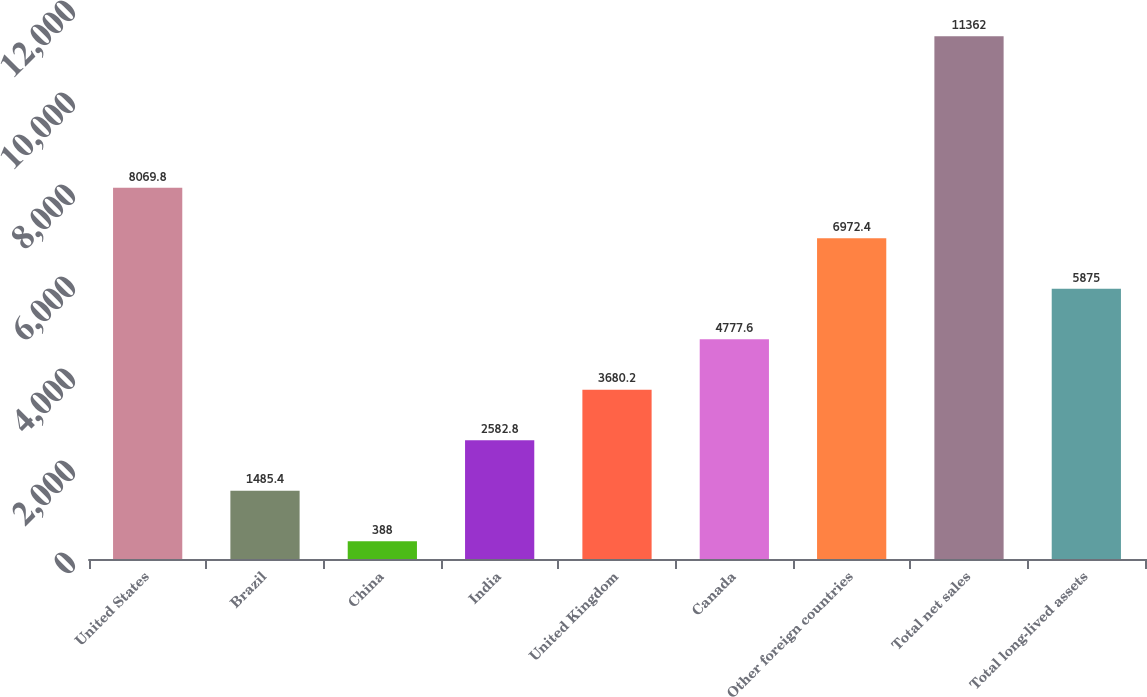Convert chart. <chart><loc_0><loc_0><loc_500><loc_500><bar_chart><fcel>United States<fcel>Brazil<fcel>China<fcel>India<fcel>United Kingdom<fcel>Canada<fcel>Other foreign countries<fcel>Total net sales<fcel>Total long-lived assets<nl><fcel>8069.8<fcel>1485.4<fcel>388<fcel>2582.8<fcel>3680.2<fcel>4777.6<fcel>6972.4<fcel>11362<fcel>5875<nl></chart> 